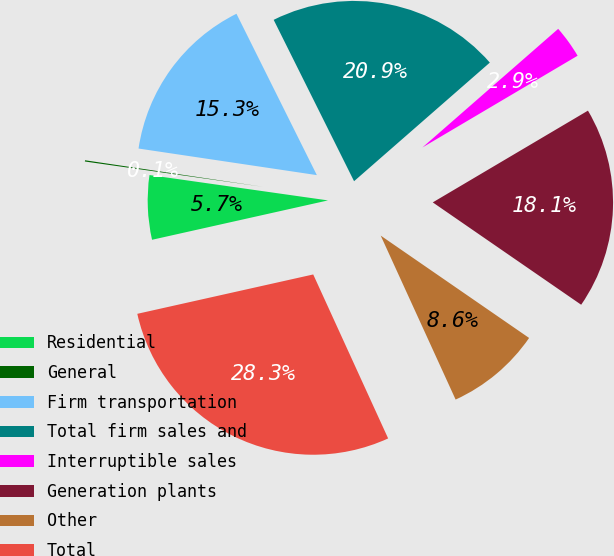Convert chart to OTSL. <chart><loc_0><loc_0><loc_500><loc_500><pie_chart><fcel>Residential<fcel>General<fcel>Firm transportation<fcel>Total firm sales and<fcel>Interruptible sales<fcel>Generation plants<fcel>Other<fcel>Total<nl><fcel>5.75%<fcel>0.11%<fcel>15.29%<fcel>20.93%<fcel>2.93%<fcel>18.11%<fcel>8.57%<fcel>28.32%<nl></chart> 